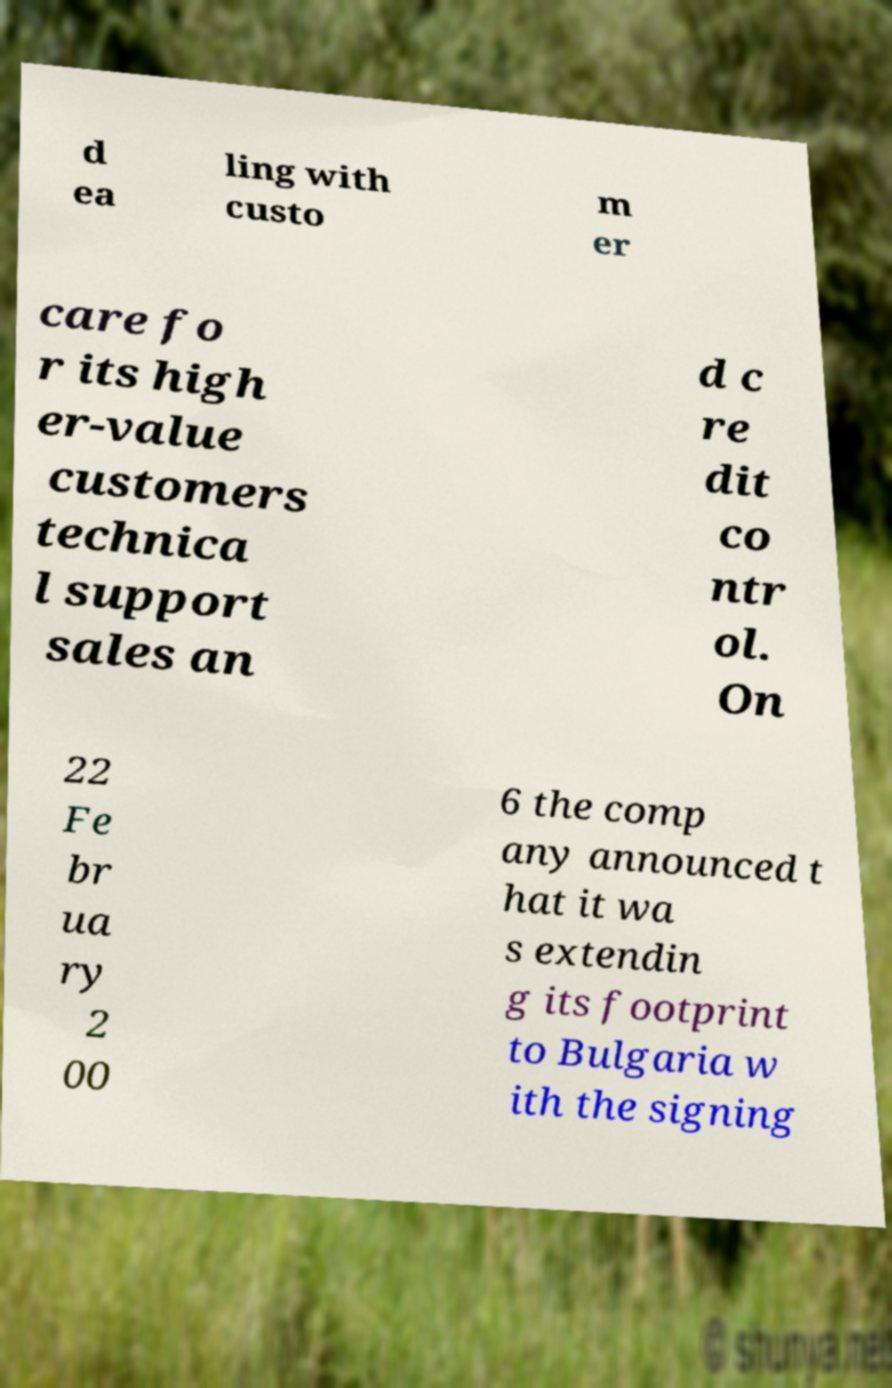Can you read and provide the text displayed in the image?This photo seems to have some interesting text. Can you extract and type it out for me? d ea ling with custo m er care fo r its high er-value customers technica l support sales an d c re dit co ntr ol. On 22 Fe br ua ry 2 00 6 the comp any announced t hat it wa s extendin g its footprint to Bulgaria w ith the signing 